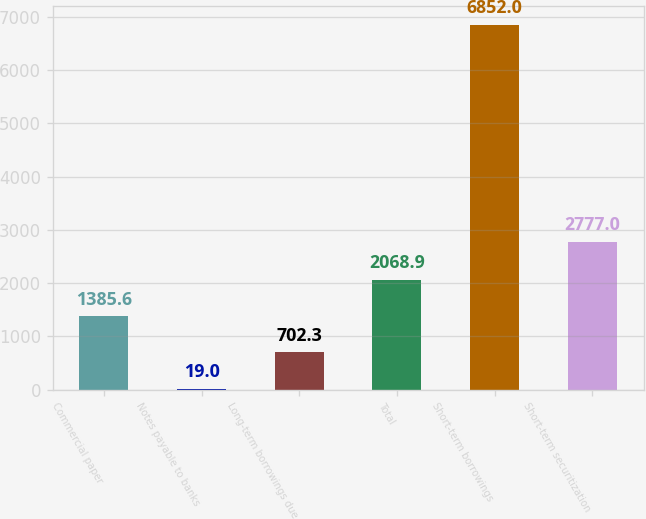<chart> <loc_0><loc_0><loc_500><loc_500><bar_chart><fcel>Commercial paper<fcel>Notes payable to banks<fcel>Long-term borrowings due<fcel>Total<fcel>Short-term borrowings<fcel>Short-term securitization<nl><fcel>1385.6<fcel>19<fcel>702.3<fcel>2068.9<fcel>6852<fcel>2777<nl></chart> 